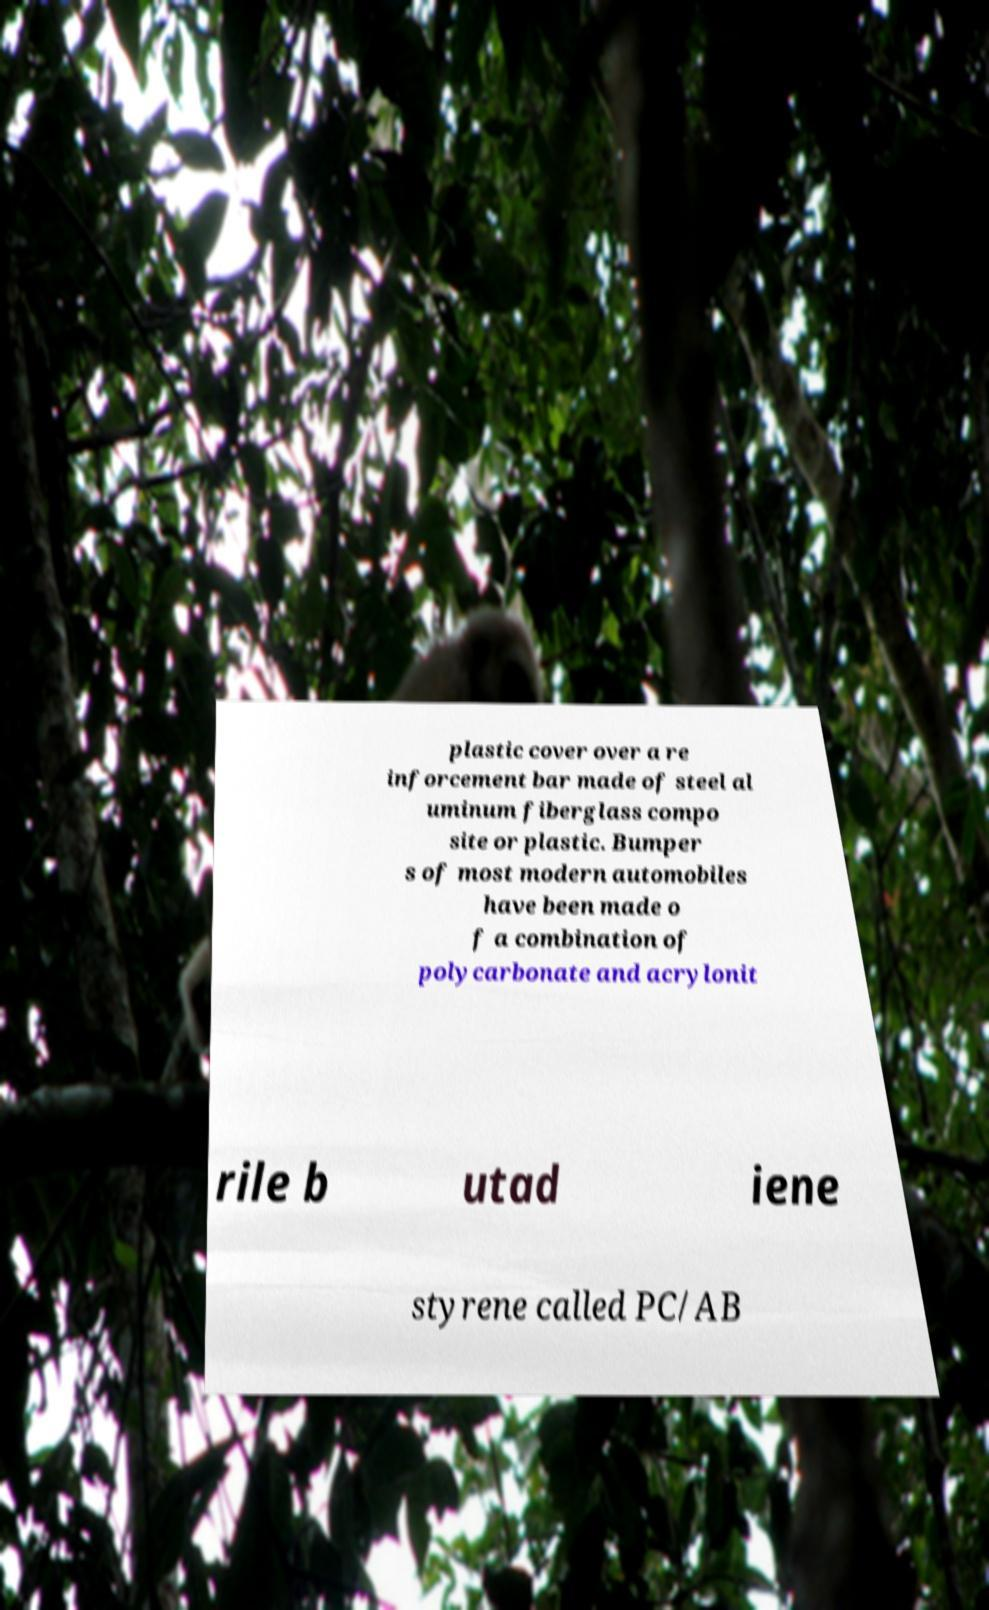Please identify and transcribe the text found in this image. plastic cover over a re inforcement bar made of steel al uminum fiberglass compo site or plastic. Bumper s of most modern automobiles have been made o f a combination of polycarbonate and acrylonit rile b utad iene styrene called PC/AB 